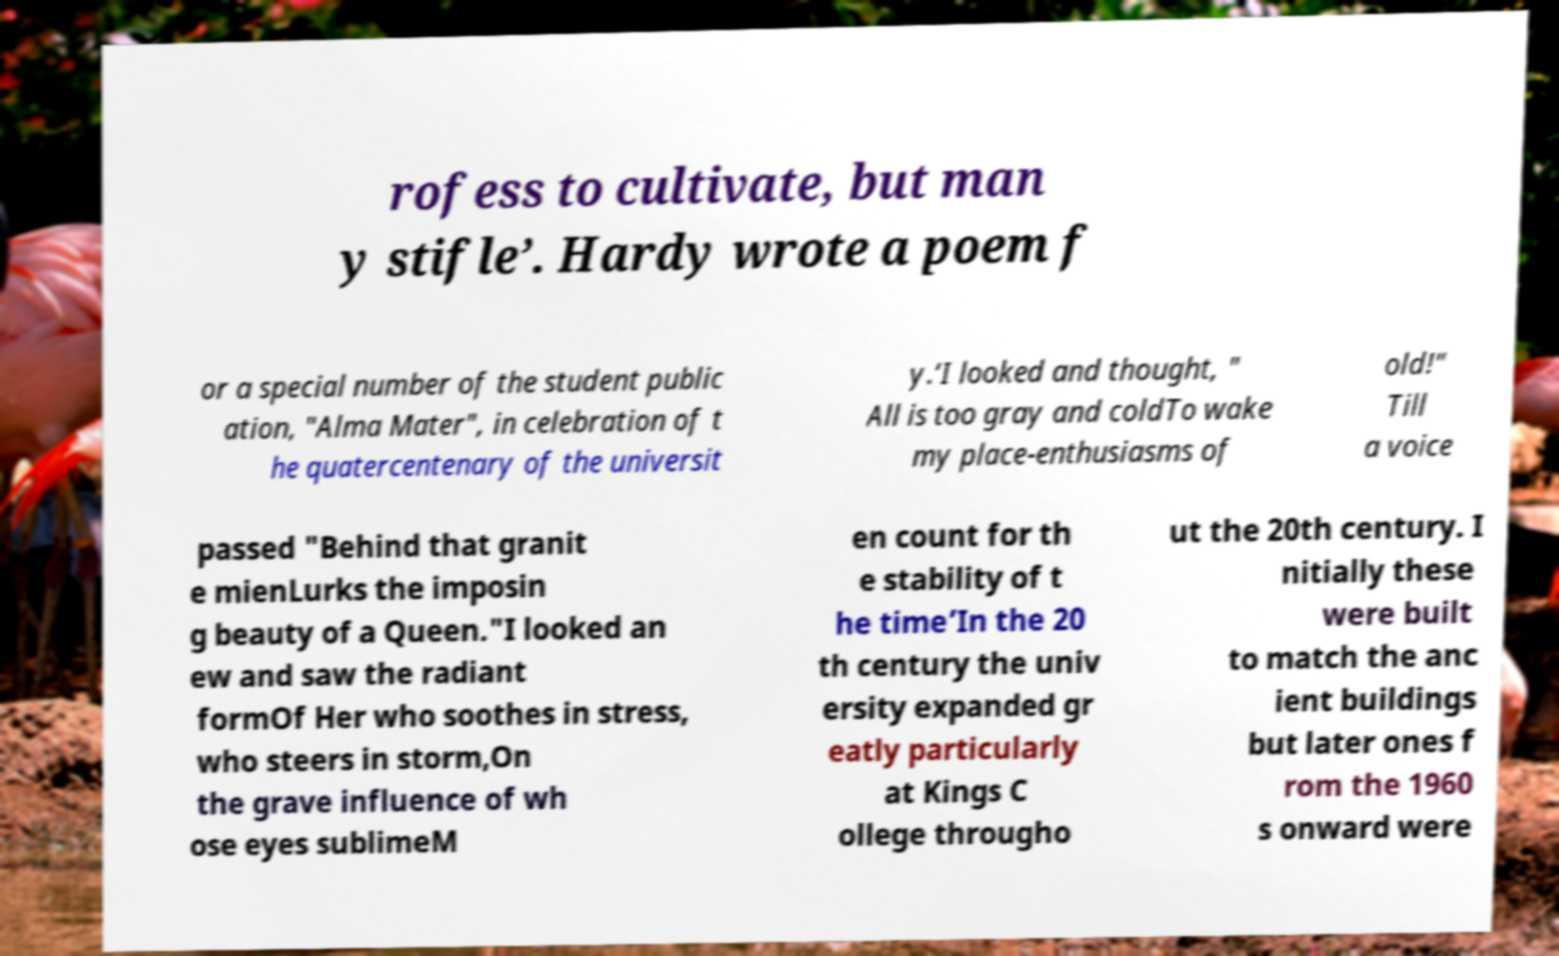Could you assist in decoding the text presented in this image and type it out clearly? rofess to cultivate, but man y stifle’. Hardy wrote a poem f or a special number of the student public ation, "Alma Mater", in celebration of t he quatercentenary of the universit y.‘I looked and thought, " All is too gray and coldTo wake my place-enthusiasms of old!" Till a voice passed "Behind that granit e mienLurks the imposin g beauty of a Queen."I looked an ew and saw the radiant formOf Her who soothes in stress, who steers in storm,On the grave influence of wh ose eyes sublimeM en count for th e stability of t he time’In the 20 th century the univ ersity expanded gr eatly particularly at Kings C ollege througho ut the 20th century. I nitially these were built to match the anc ient buildings but later ones f rom the 1960 s onward were 